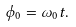Convert formula to latex. <formula><loc_0><loc_0><loc_500><loc_500>\phi _ { 0 } = \omega _ { 0 } t .</formula> 